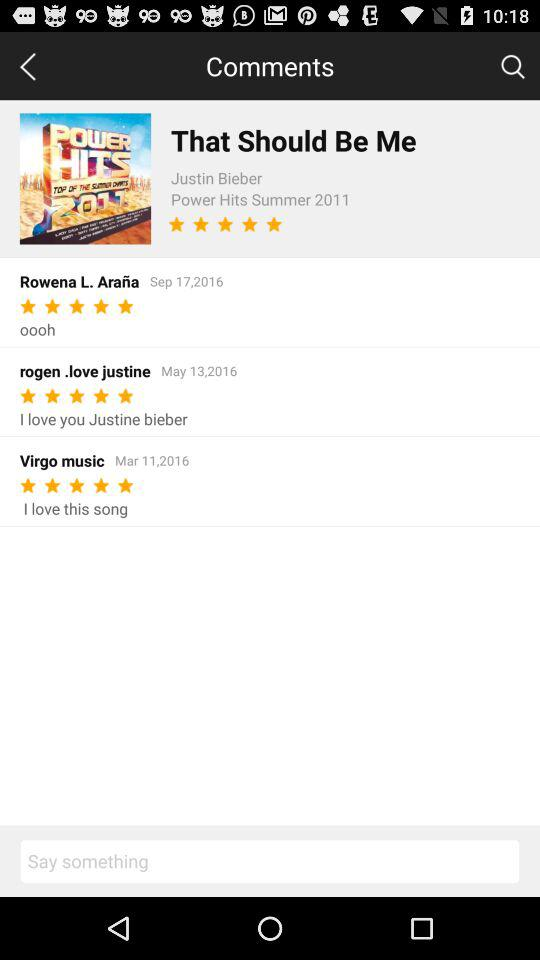On what date did "rogen.love justine" write the review? "rogen.love justine" wrote the review on May 13, 2016. 